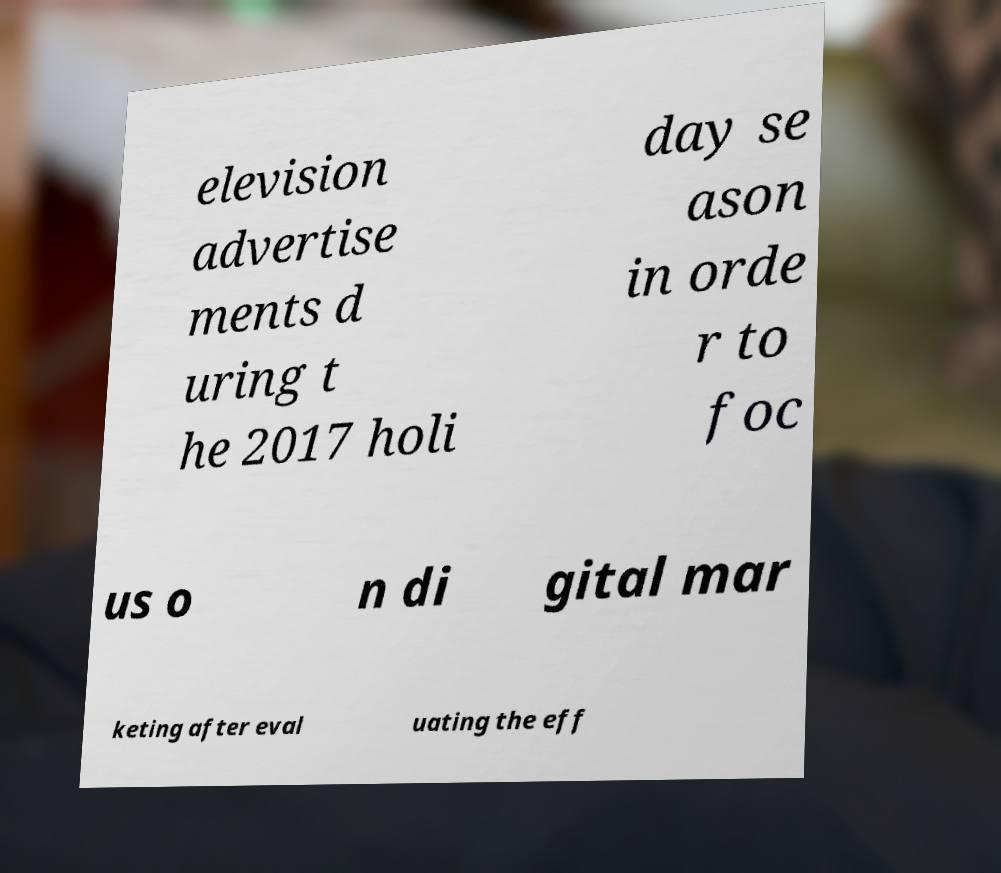I need the written content from this picture converted into text. Can you do that? elevision advertise ments d uring t he 2017 holi day se ason in orde r to foc us o n di gital mar keting after eval uating the eff 